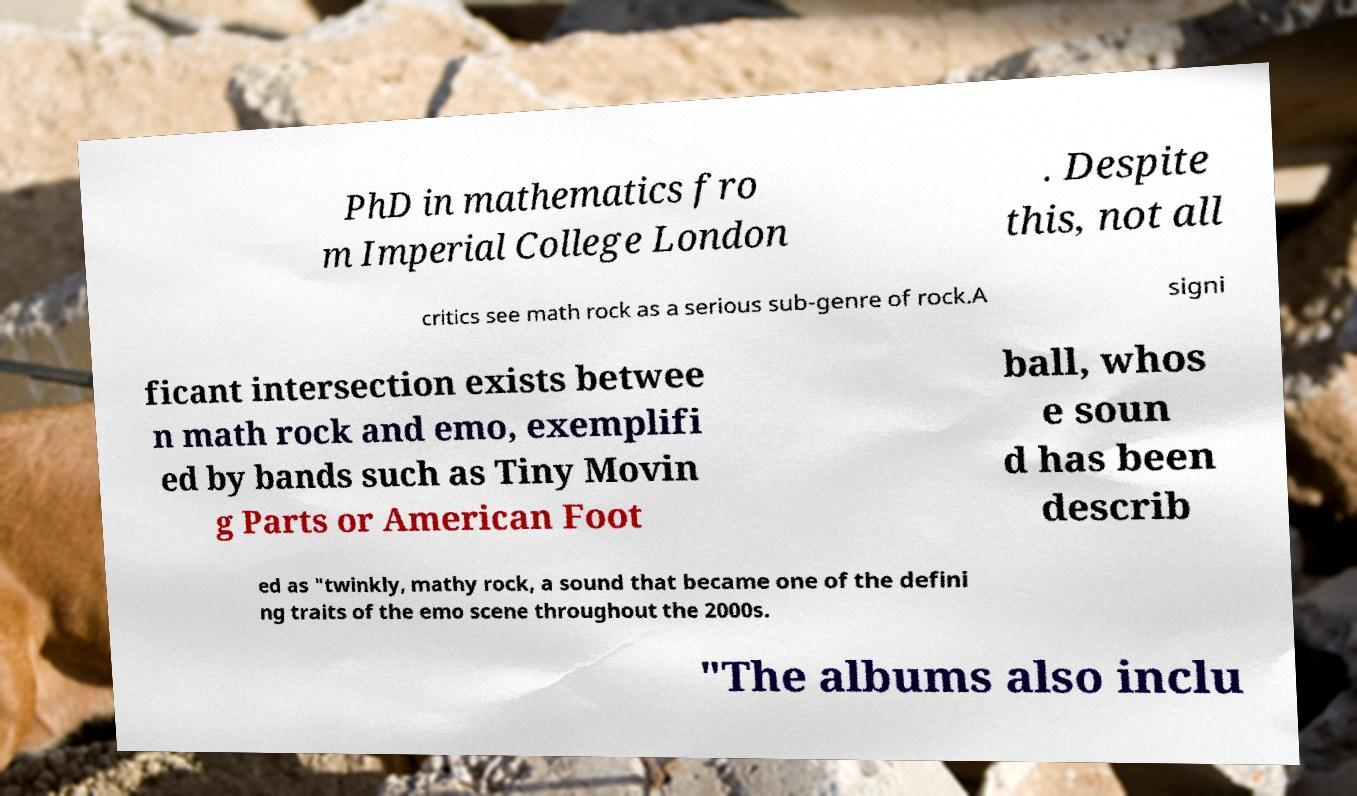Please identify and transcribe the text found in this image. PhD in mathematics fro m Imperial College London . Despite this, not all critics see math rock as a serious sub-genre of rock.A signi ficant intersection exists betwee n math rock and emo, exemplifi ed by bands such as Tiny Movin g Parts or American Foot ball, whos e soun d has been describ ed as "twinkly, mathy rock, a sound that became one of the defini ng traits of the emo scene throughout the 2000s. "The albums also inclu 